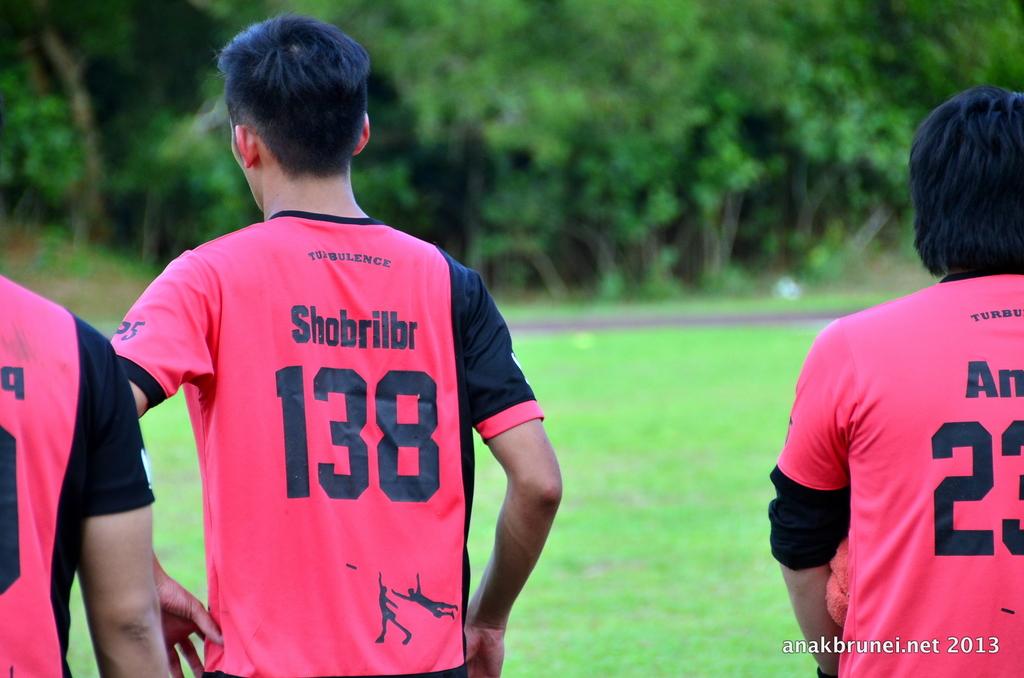Who is player number 138?
Your answer should be compact. Shobrilbr. What number is being cut off on the right side of the image?
Your answer should be very brief. 23. 